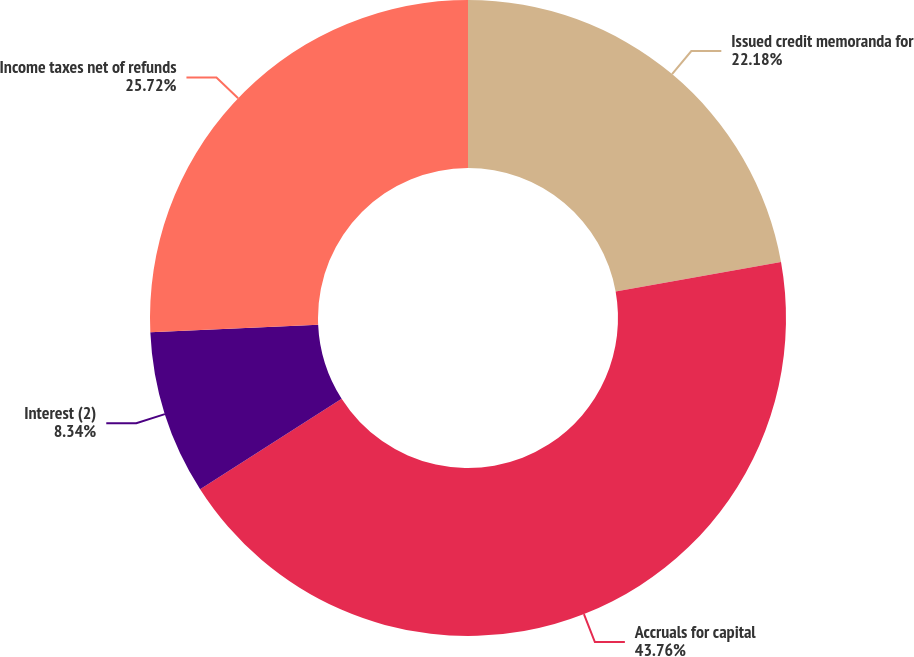Convert chart to OTSL. <chart><loc_0><loc_0><loc_500><loc_500><pie_chart><fcel>Issued credit memoranda for<fcel>Accruals for capital<fcel>Interest (2)<fcel>Income taxes net of refunds<nl><fcel>22.18%<fcel>43.77%<fcel>8.34%<fcel>25.72%<nl></chart> 